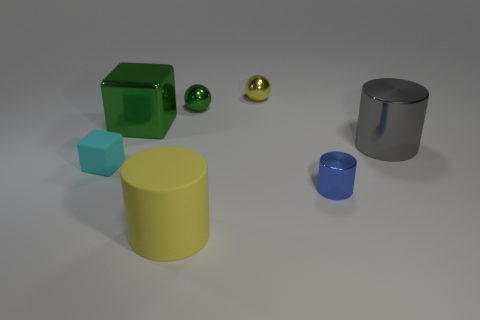Subtract all small cylinders. How many cylinders are left? 2 Subtract all green cubes. How many cubes are left? 1 Subtract all green cylinders. Subtract all red balls. How many cylinders are left? 3 Subtract all gray cylinders. How many green spheres are left? 1 Subtract all big gray matte cylinders. Subtract all large green metal cubes. How many objects are left? 6 Add 6 green objects. How many green objects are left? 8 Add 5 large gray objects. How many large gray objects exist? 6 Add 2 green matte cubes. How many objects exist? 9 Subtract 1 green balls. How many objects are left? 6 Subtract all cylinders. How many objects are left? 4 